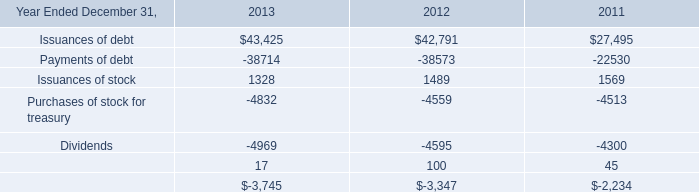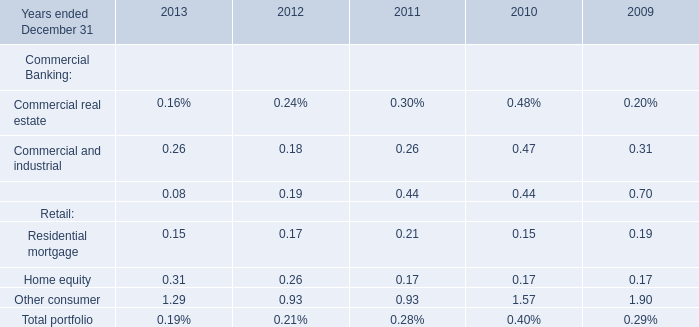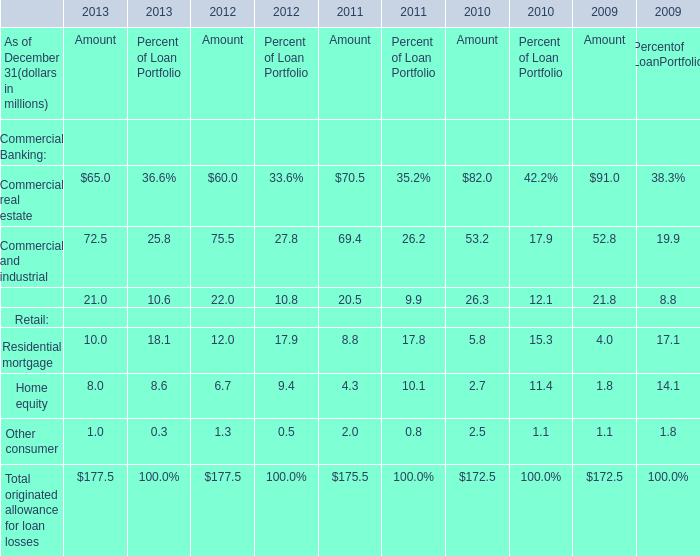Which element for Amout makes up more than 20% of the total in 2011? 
Answer: Commercial real estate, Commercial and industrial. 